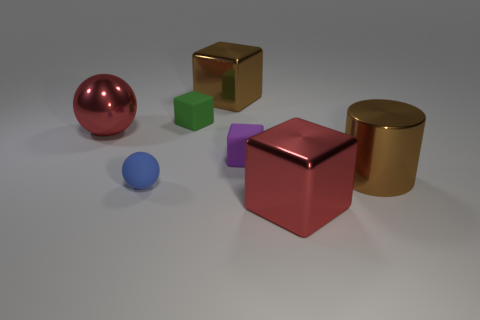Subtract all large brown blocks. How many blocks are left? 3 Subtract all purple blocks. How many blocks are left? 3 Add 4 shiny cylinders. How many shiny cylinders exist? 5 Add 1 big blue metal objects. How many objects exist? 8 Subtract 1 red cubes. How many objects are left? 6 Subtract all cylinders. How many objects are left? 6 Subtract all yellow cylinders. Subtract all green blocks. How many cylinders are left? 1 Subtract all tiny balls. Subtract all rubber blocks. How many objects are left? 4 Add 5 red shiny objects. How many red shiny objects are left? 7 